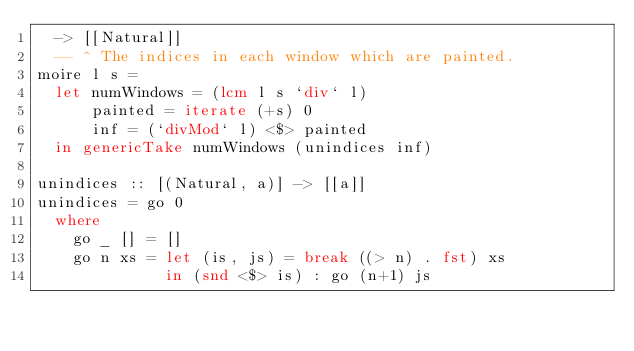Convert code to text. <code><loc_0><loc_0><loc_500><loc_500><_Haskell_>  -> [[Natural]]
  -- ^ The indices in each window which are painted.
moire l s =
  let numWindows = (lcm l s `div` l)
      painted = iterate (+s) 0
      inf = (`divMod` l) <$> painted
  in genericTake numWindows (unindices inf)

unindices :: [(Natural, a)] -> [[a]]
unindices = go 0
  where
    go _ [] = []
    go n xs = let (is, js) = break ((> n) . fst) xs
              in (snd <$> is) : go (n+1) js
</code> 